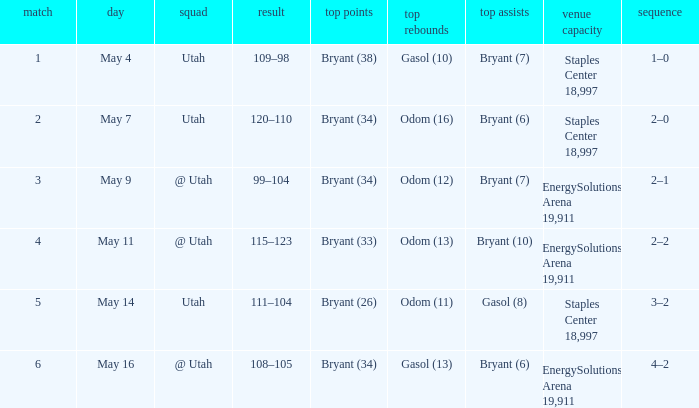What is the High rebounds with a Series with 4–2? Gasol (13). 